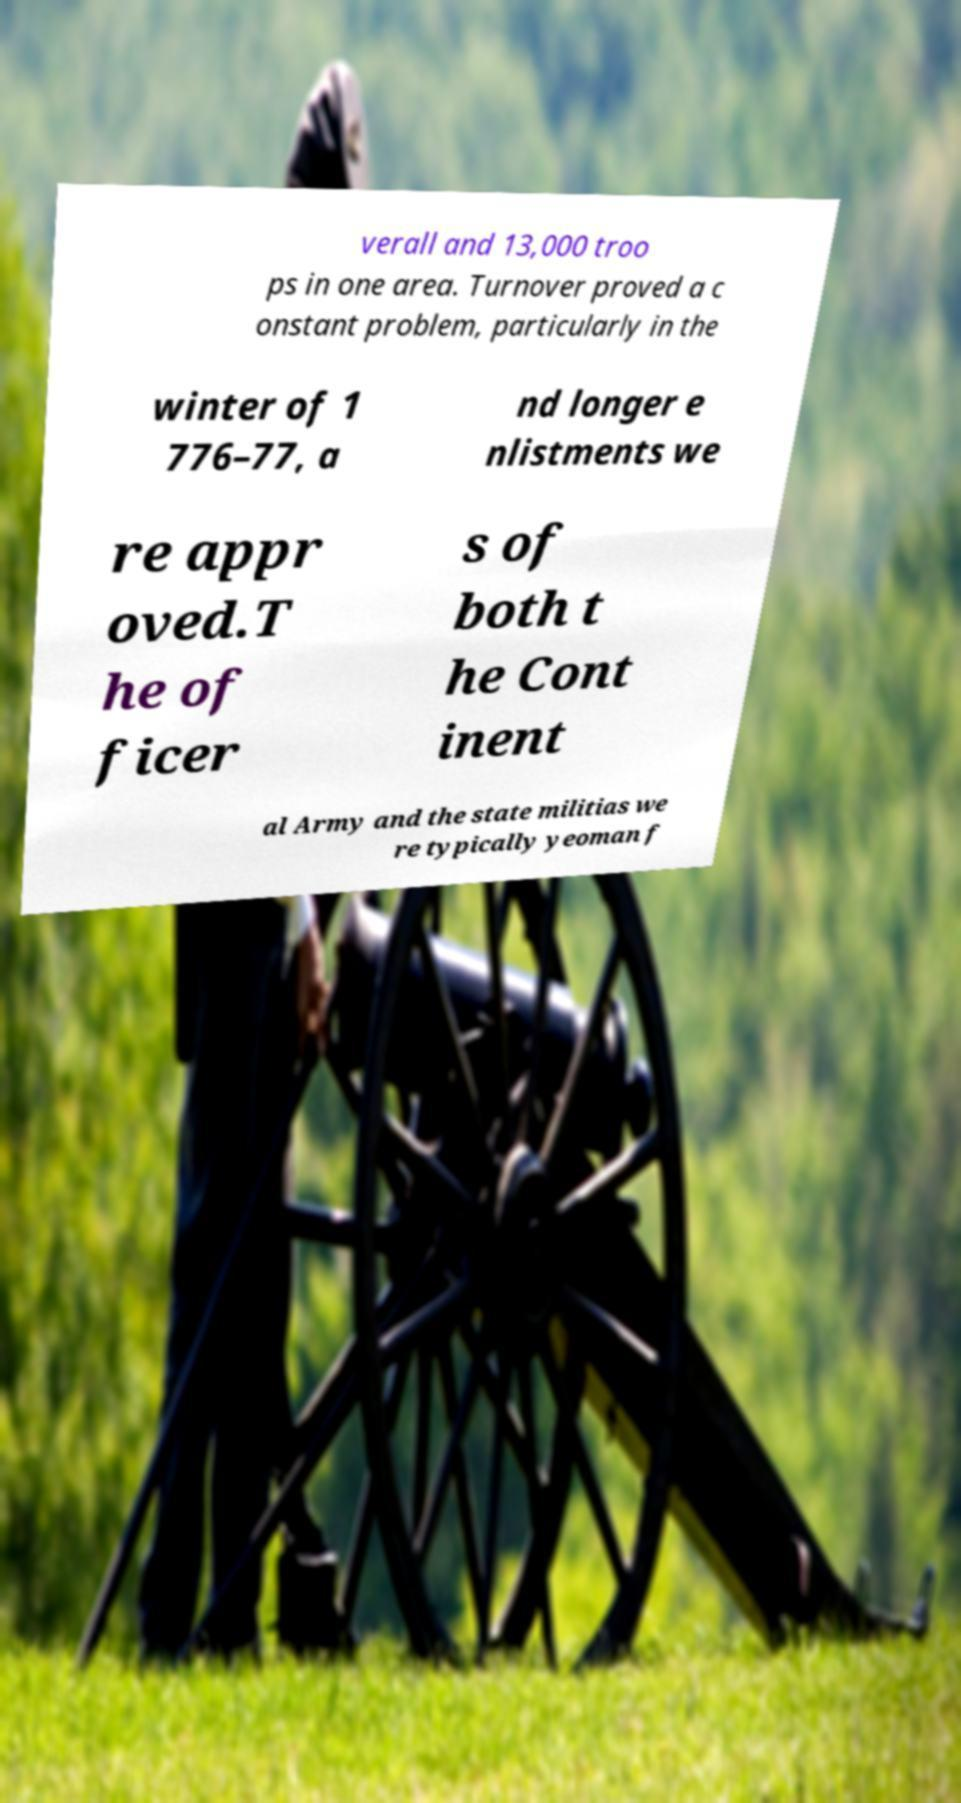Please identify and transcribe the text found in this image. verall and 13,000 troo ps in one area. Turnover proved a c onstant problem, particularly in the winter of 1 776–77, a nd longer e nlistments we re appr oved.T he of ficer s of both t he Cont inent al Army and the state militias we re typically yeoman f 